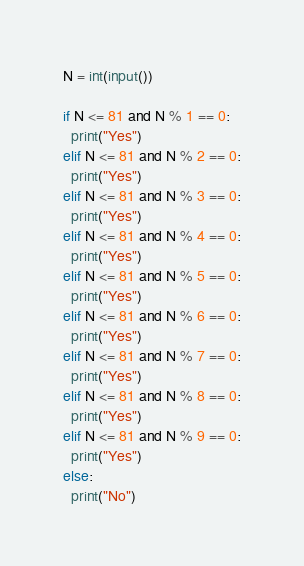<code> <loc_0><loc_0><loc_500><loc_500><_Python_>N = int(input())

if N <= 81 and N % 1 == 0:
  print("Yes")
elif N <= 81 and N % 2 == 0:
  print("Yes")
elif N <= 81 and N % 3 == 0:
  print("Yes")
elif N <= 81 and N % 4 == 0:
  print("Yes")
elif N <= 81 and N % 5 == 0:
  print("Yes")
elif N <= 81 and N % 6 == 0:
  print("Yes")
elif N <= 81 and N % 7 == 0:
  print("Yes")
elif N <= 81 and N % 8 == 0:
  print("Yes")
elif N <= 81 and N % 9 == 0:
  print("Yes")
else:
  print("No")</code> 